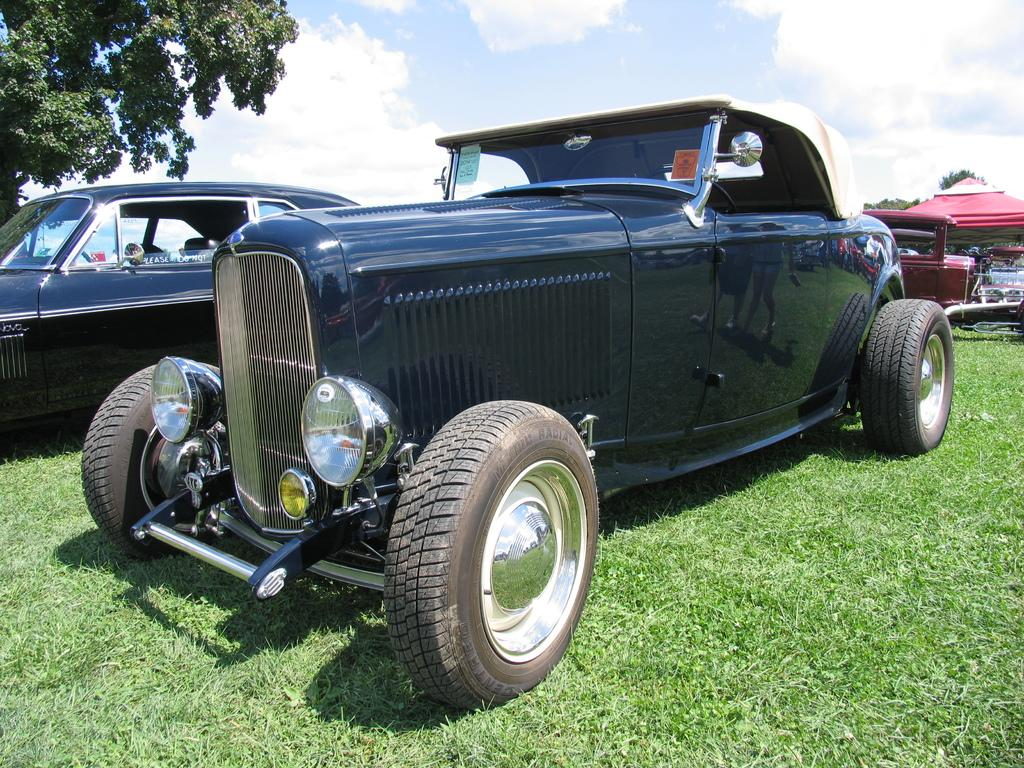What is the surface on which the vehicles are placed in the image? The vehicles are on the green grass in the image. What can be seen on the left side of the image? There is a tree on the left side of the image. What is visible in the sky in the image? Clouds are visible in the sky in the image. What type of sponge can be seen floating in the water in the image? There is no water or sponge present in the image; it features vehicles on green grass with a tree on the left side and clouds in the sky. 